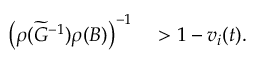Convert formula to latex. <formula><loc_0><loc_0><loc_500><loc_500>\begin{array} { r l } { \left ( \rho ( \widetilde { G } ^ { - 1 } ) \rho ( B ) \right ) ^ { - 1 } } & > 1 - v _ { i } ( t ) . } \end{array}</formula> 